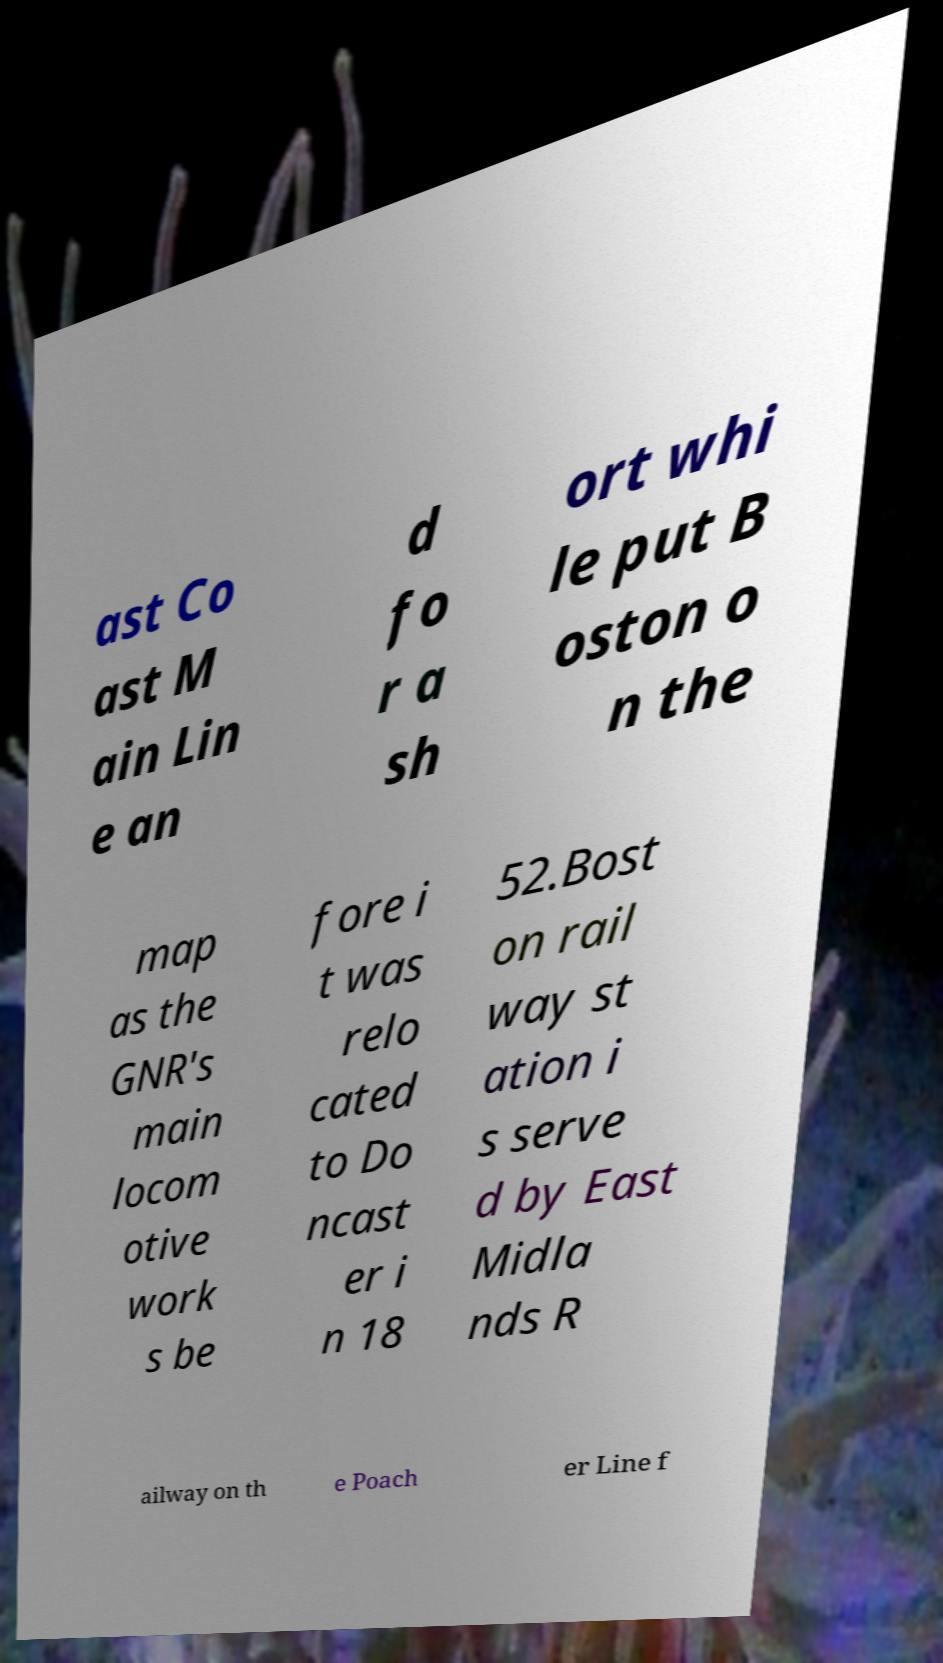Can you accurately transcribe the text from the provided image for me? ast Co ast M ain Lin e an d fo r a sh ort whi le put B oston o n the map as the GNR's main locom otive work s be fore i t was relo cated to Do ncast er i n 18 52.Bost on rail way st ation i s serve d by East Midla nds R ailway on th e Poach er Line f 